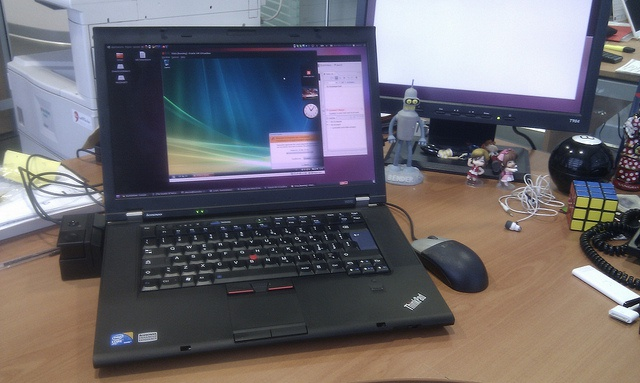Describe the objects in this image and their specific colors. I can see laptop in gray, black, navy, and blue tones, keyboard in gray and black tones, and mouse in gray, black, and darkgray tones in this image. 